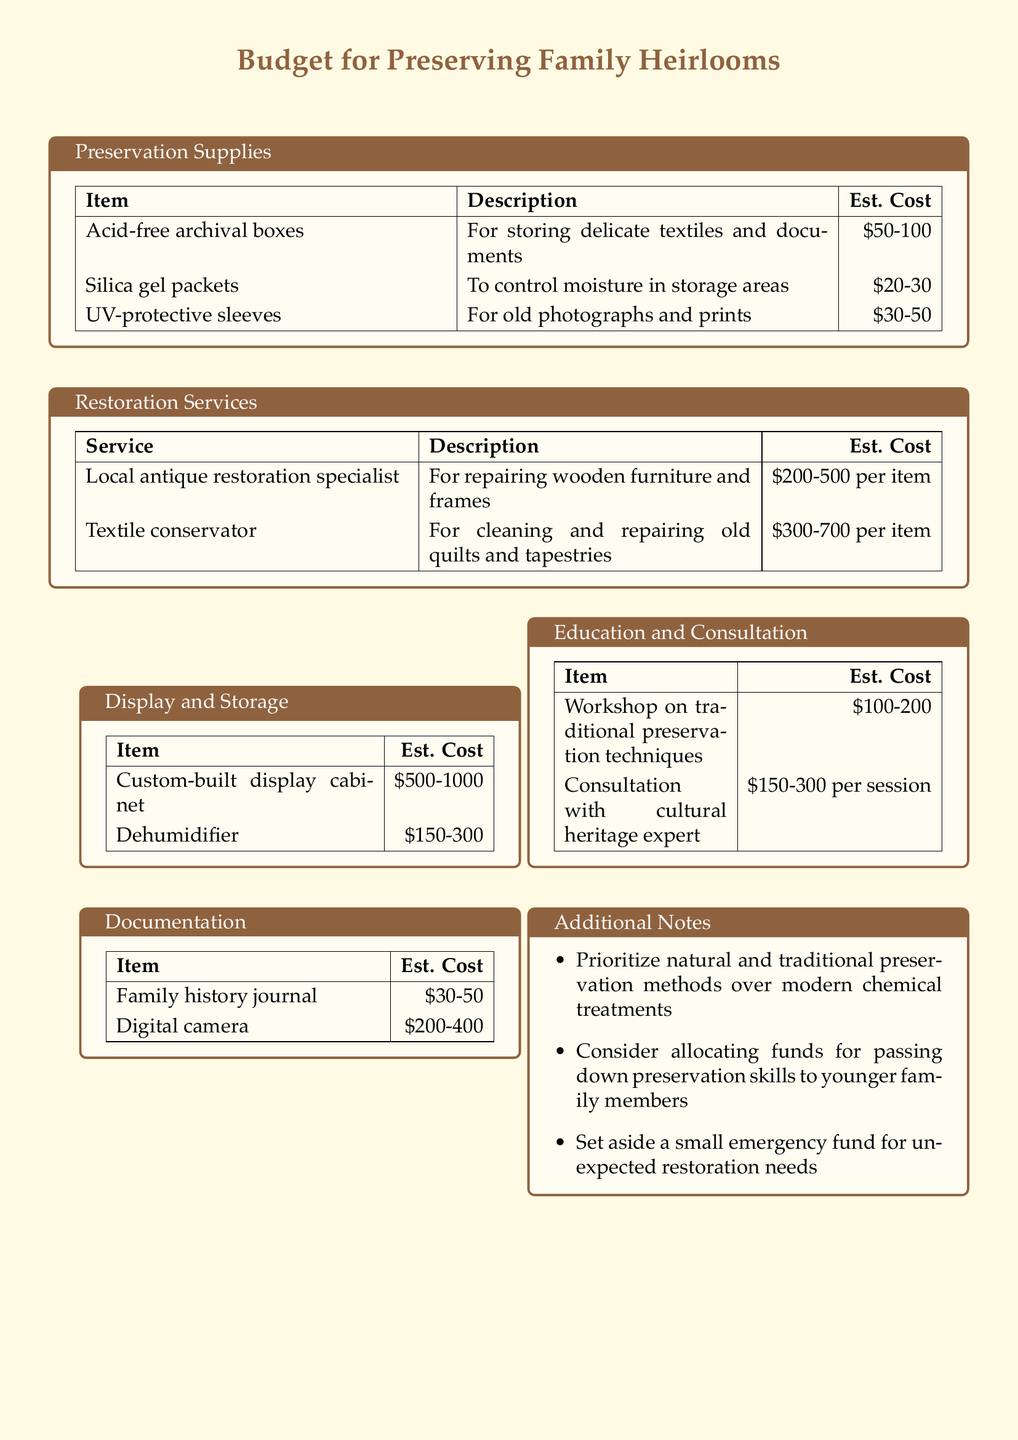What is the estimated cost of UV-protective sleeves? The estimated cost of UV-protective sleeves is listed in the Preservation Supplies section of the document.
Answer: $30-50 How much can a textile conservator cost per item? The document states the estimated cost of the textile conservator service in the Restoration Services section.
Answer: $300-700 What is one of the priorities mentioned for preservation methods? The Additional Notes section highlights a specific approach to preservation that is emphasized.
Answer: Traditional preservation methods What is the estimated cost range for a custom-built display cabinet? The estimated costs are provided in the Display and Storage section of the document.
Answer: $500-1000 What is a suggested item for keeping moisture under control? It can be found in the Preservation Supplies section as a moisture-controlling item.
Answer: Silica gel packets What is the estimated cost for a consultation with a cultural heritage expert? This cost is specified in the Education and Consultation section of the document.
Answer: $150-300 per session What item is suggested for family history documentation? The Documentation section contains a recommended item for this purpose.
Answer: Family history journal How much should be set aside for unexpected restoration needs? The Additional Notes section mentions this suggestion related to financial planning.
Answer: Emergency fund 